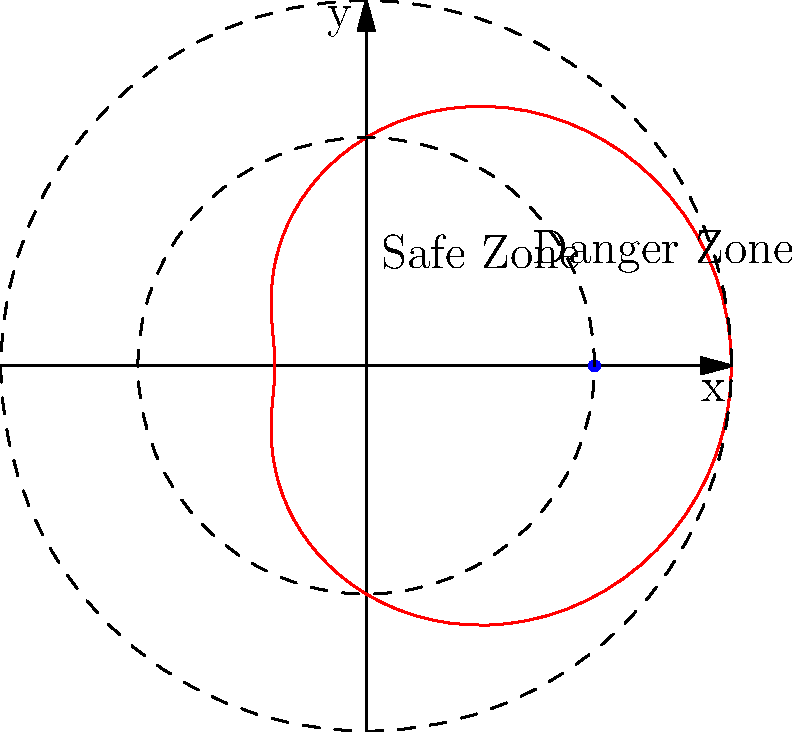In a simulated missile threat scenario, a safe zone is defined by a polar curve $r = 5 + 3\cos(\theta)$. If a critical military asset is located at the point (5, 0), determine whether it falls within the safe zone or the danger zone. To solve this problem, we'll follow these steps:

1) The polar curve $r = 5 + 3\cos(\theta)$ defines the boundary between the safe and danger zones.

2) The critical military asset is located at the point (5, 0) in Cartesian coordinates.

3) To determine if this point is inside or outside the safe zone, we need to convert (5, 0) to polar coordinates:
   $r = \sqrt{5^2 + 0^2} = 5$
   $\theta = \arctan(0/5) = 0$

4) Now, we substitute $\theta = 0$ into the equation of the boundary:
   $r = 5 + 3\cos(0) = 5 + 3 = 8$

5) This means that at $\theta = 0$, the boundary is at a distance of 8 from the origin.

6) Since our point (5, 0) has $r = 5$, which is less than 8, it falls inside the boundary curve.

7) The safe zone is the region enclosed by the curve, closer to the origin.

Therefore, the critical military asset at (5, 0) is within the safe zone.
Answer: Safe zone 